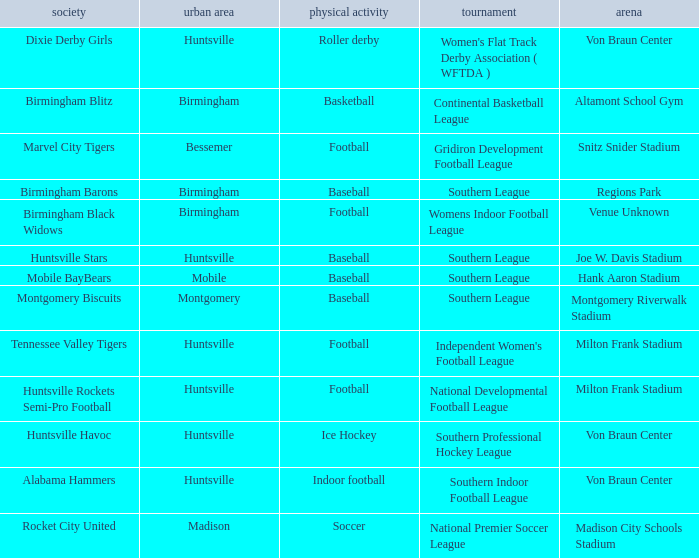Which sport was held in Huntsville at the Von Braun Center as part of the Southern Indoor Football League? Indoor football. 